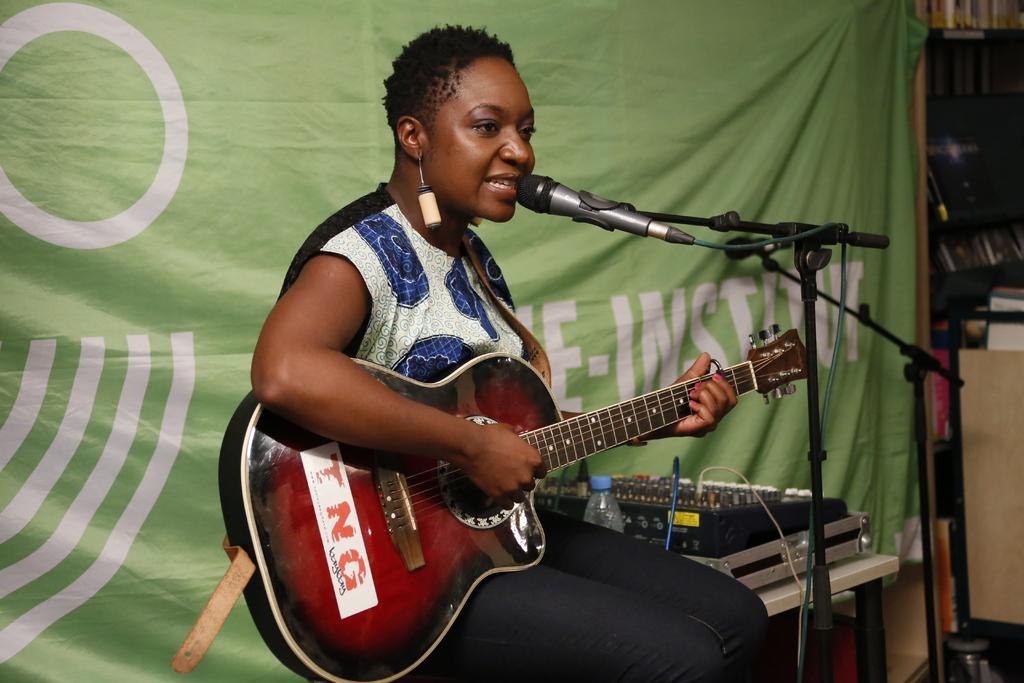Who is the main subject in the image? There is a woman in the image. What is the woman doing in the image? The woman is sitting, playing a guitar, and singing. What object is in front of the woman? There is a microphone in front of the woman. What type of rice can be seen on the playground in the image? There is no playground or rice present in the image. What is the woman using to carry her tray of food in the image? There is no tray or food present in the image. 